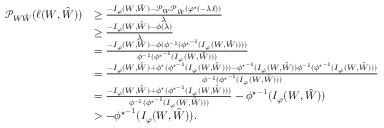<formula> <loc_0><loc_0><loc_500><loc_500>\begin{array} { r l } { \mathcal { P } _ { W \hat { W } } ( \ell ( W , \hat { W } ) ) } & { \geq \frac { - I _ { \varphi } ( W , \hat { W } ) - \mathcal { P } _ { W } \mathcal { P } _ { \hat { W } } \left ( \varphi ^ { ^ { * } } ( - \lambda \ell ) \right ) } { \lambda } } \\ & { \geq \frac { - I _ { \varphi } ( W , \hat { W } ) - \phi ( \lambda ) } { \lambda } } \\ & { = \frac { - I _ { \varphi } ( W , \hat { W } ) - \phi ( \phi ^ { - 1 } ( { \phi ^ { ^ { * } } } ^ { - 1 } ( I _ { \varphi } ( W , \hat { W } ) ) ) ) } { \phi ^ { - 1 } ( { \phi ^ { ^ { * } } } ^ { - 1 } ( I _ { \varphi } ( W , \hat { W } ) ) ) } } \\ & { = \frac { - I _ { \varphi } ( W , \hat { W } ) + \phi ^ { ^ { * } } ( { \phi ^ { ^ { * } } } ^ { - 1 } ( I _ { \varphi } ( W , \hat { W } ) ) ) - { \phi ^ { ^ { * } } } ^ { - 1 } ( I _ { \varphi } ( W , \hat { W } ) ) \phi ^ { - 1 } ( { \phi ^ { ^ { * } } } ^ { - 1 } ( I _ { \varphi } ( W , \hat { W } ) ) ) } { \phi ^ { - 1 } ( { \phi ^ { ^ { * } } } ^ { - 1 } ( I _ { \varphi } ( W , \hat { W } ) ) ) } } \\ & { = \frac { - I _ { \varphi } ( W , \hat { W } ) + \phi ^ { ^ { * } } ( { \phi ^ { ^ { * } } } ^ { - 1 } ( I _ { \varphi } ( W , \hat { W } ) ) ) } { \phi ^ { - 1 } ( { \phi ^ { ^ { * } } } ^ { - 1 } ( I _ { \varphi } ( W , \hat { W } ) ) ) } - { \phi ^ { ^ { * } } } ^ { - 1 } ( I _ { \varphi } ( W , \hat { W } ) ) } \\ & { > - { \phi ^ { ^ { * } } } ^ { - 1 } ( I _ { \varphi } ( W , \hat { W } ) ) . } \end{array}</formula> 